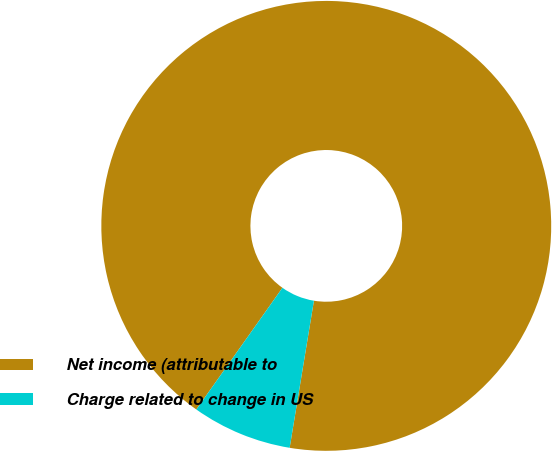<chart> <loc_0><loc_0><loc_500><loc_500><pie_chart><fcel>Net income (attributable to<fcel>Charge related to change in US<nl><fcel>92.8%<fcel>7.2%<nl></chart> 